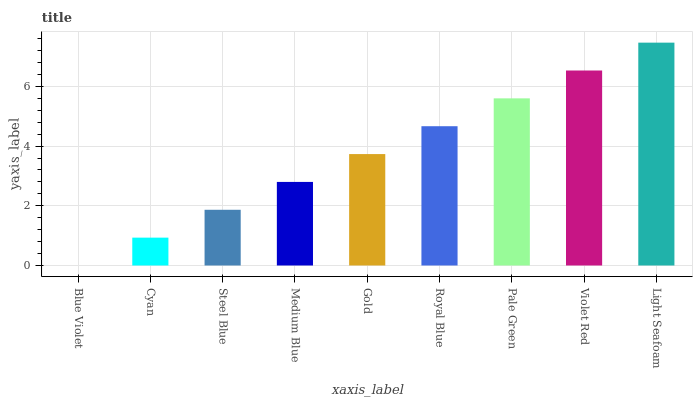Is Blue Violet the minimum?
Answer yes or no. Yes. Is Light Seafoam the maximum?
Answer yes or no. Yes. Is Cyan the minimum?
Answer yes or no. No. Is Cyan the maximum?
Answer yes or no. No. Is Cyan greater than Blue Violet?
Answer yes or no. Yes. Is Blue Violet less than Cyan?
Answer yes or no. Yes. Is Blue Violet greater than Cyan?
Answer yes or no. No. Is Cyan less than Blue Violet?
Answer yes or no. No. Is Gold the high median?
Answer yes or no. Yes. Is Gold the low median?
Answer yes or no. Yes. Is Medium Blue the high median?
Answer yes or no. No. Is Blue Violet the low median?
Answer yes or no. No. 